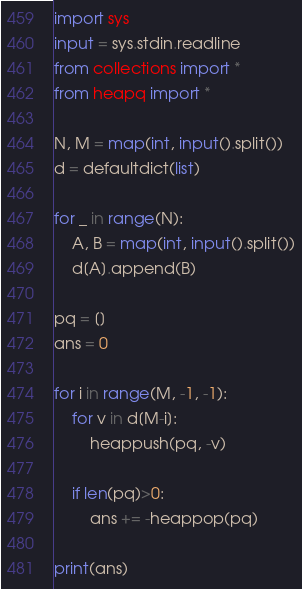Convert code to text. <code><loc_0><loc_0><loc_500><loc_500><_Python_>import sys
input = sys.stdin.readline
from collections import *
from heapq import *

N, M = map(int, input().split())
d = defaultdict(list)

for _ in range(N):
    A, B = map(int, input().split())
    d[A].append(B)

pq = []
ans = 0

for i in range(M, -1, -1):
    for v in d[M-i]:
        heappush(pq, -v)
    
    if len(pq)>0:
        ans += -heappop(pq)

print(ans)</code> 